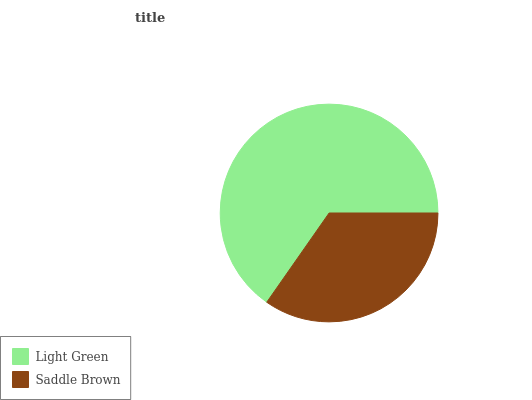Is Saddle Brown the minimum?
Answer yes or no. Yes. Is Light Green the maximum?
Answer yes or no. Yes. Is Saddle Brown the maximum?
Answer yes or no. No. Is Light Green greater than Saddle Brown?
Answer yes or no. Yes. Is Saddle Brown less than Light Green?
Answer yes or no. Yes. Is Saddle Brown greater than Light Green?
Answer yes or no. No. Is Light Green less than Saddle Brown?
Answer yes or no. No. Is Light Green the high median?
Answer yes or no. Yes. Is Saddle Brown the low median?
Answer yes or no. Yes. Is Saddle Brown the high median?
Answer yes or no. No. Is Light Green the low median?
Answer yes or no. No. 